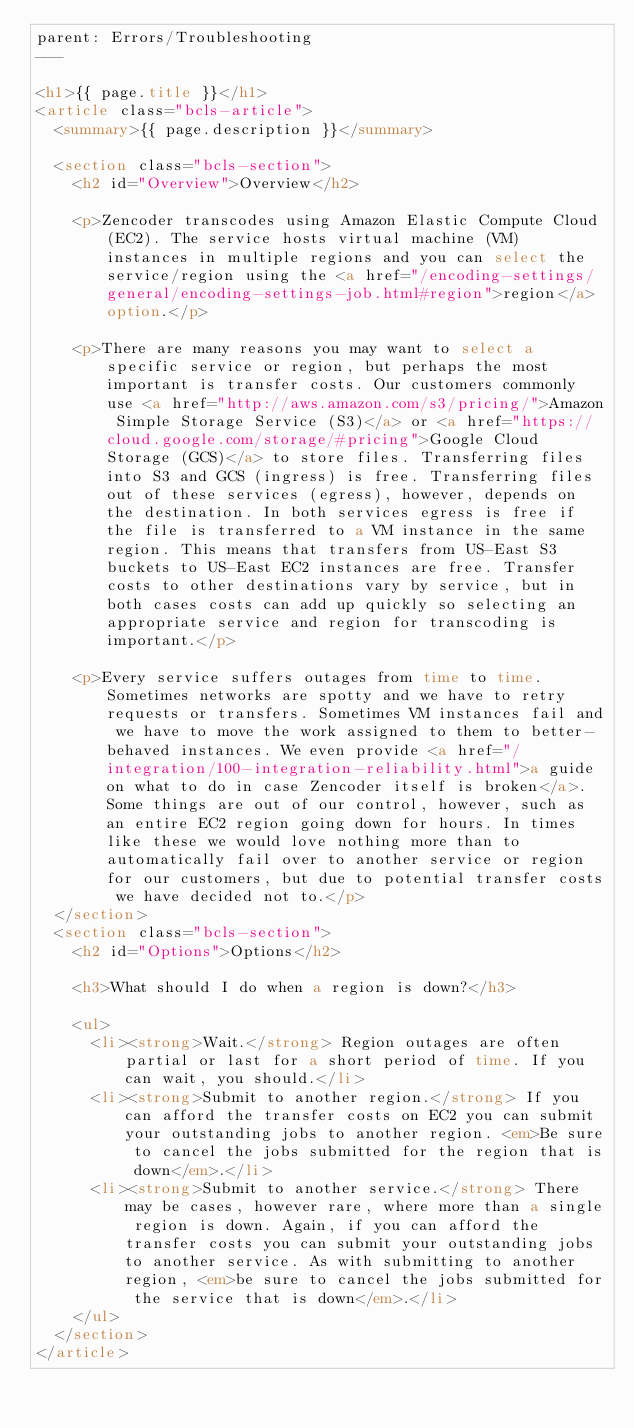<code> <loc_0><loc_0><loc_500><loc_500><_HTML_>parent: Errors/Troubleshooting
---

<h1>{{ page.title }}</h1>
<article class="bcls-article">
  <summary>{{ page.description }}</summary>

  <section class="bcls-section">
    <h2 id="Overview">Overview</h2>

    <p>Zencoder transcodes using Amazon Elastic Compute Cloud (EC2). The service hosts virtual machine (VM) instances in multiple regions and you can select the service/region using the <a href="/encoding-settings/general/encoding-settings-job.html#region">region</a> option.</p>

    <p>There are many reasons you may want to select a specific service or region, but perhaps the most important is transfer costs. Our customers commonly use <a href="http://aws.amazon.com/s3/pricing/">Amazon Simple Storage Service (S3)</a> or <a href="https://cloud.google.com/storage/#pricing">Google Cloud Storage (GCS)</a> to store files. Transferring files into S3 and GCS (ingress) is free. Transferring files out of these services (egress), however, depends on the destination. In both services egress is free if the file is transferred to a VM instance in the same region. This means that transfers from US-East S3 buckets to US-East EC2 instances are free. Transfer costs to other destinations vary by service, but in both cases costs can add up quickly so selecting an appropriate service and region for transcoding is important.</p>

    <p>Every service suffers outages from time to time. Sometimes networks are spotty and we have to retry requests or transfers. Sometimes VM instances fail and we have to move the work assigned to them to better-behaved instances. We even provide <a href="/integration/100-integration-reliability.html">a guide on what to do in case Zencoder itself is broken</a>. Some things are out of our control, however, such as an entire EC2 region going down for hours. In times like these we would love nothing more than to automatically fail over to another service or region for our customers, but due to potential transfer costs we have decided not to.</p>
  </section>
  <section class="bcls-section">
    <h2 id="Options">Options</h2>

    <h3>What should I do when a region is down?</h3>

    <ul>
      <li><strong>Wait.</strong> Region outages are often partial or last for a short period of time. If you can wait, you should.</li>
      <li><strong>Submit to another region.</strong> If you can afford the transfer costs on EC2 you can submit your outstanding jobs to another region. <em>Be sure to cancel the jobs submitted for the region that is down</em>.</li>
      <li><strong>Submit to another service.</strong> There may be cases, however rare, where more than a single region is down. Again, if you can afford the transfer costs you can submit your outstanding jobs to another service. As with submitting to another region, <em>be sure to cancel the jobs submitted for the service that is down</em>.</li>
    </ul>
  </section>
</article></code> 